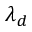Convert formula to latex. <formula><loc_0><loc_0><loc_500><loc_500>\lambda _ { d }</formula> 